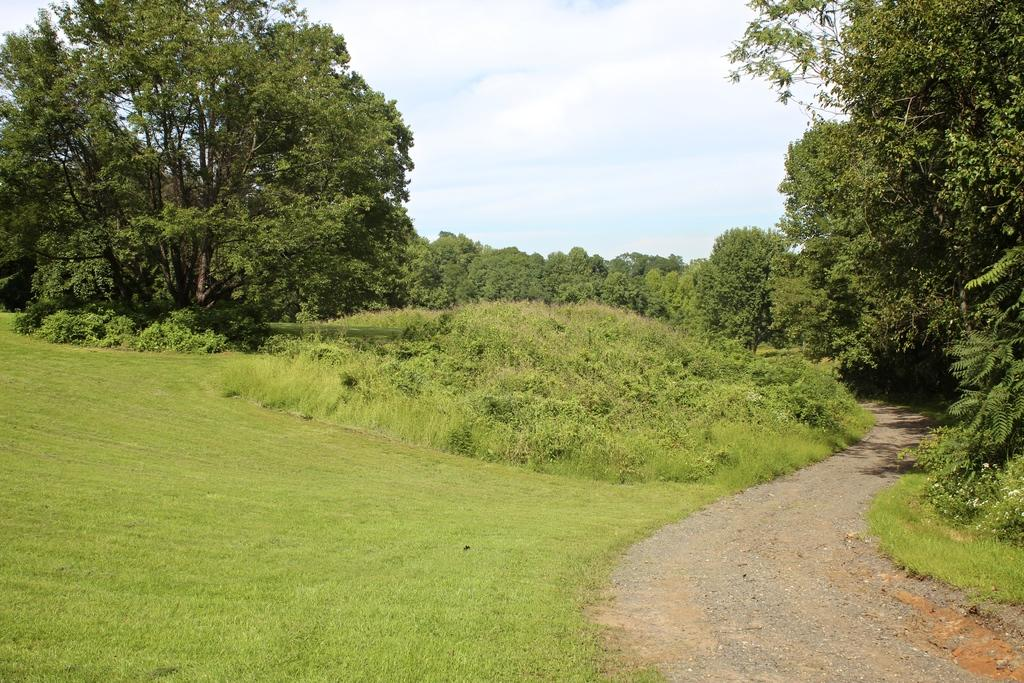What can be seen on the right side of the image? There is a road on the right side of the image. What type of vegetation is present at the bottom of the image? Grass is present on the surface at the bottom of the image. What is visible in the background of the image? There are trees and the sky visible in the background of the image. How does the image depict the level of pollution in the area? The image does not depict the level of pollution in the area; it only shows a road, grass, trees, and the sky. Is there a brother present in the image? There is no mention of a brother or any people in the image; it only shows natural elements and a road. 